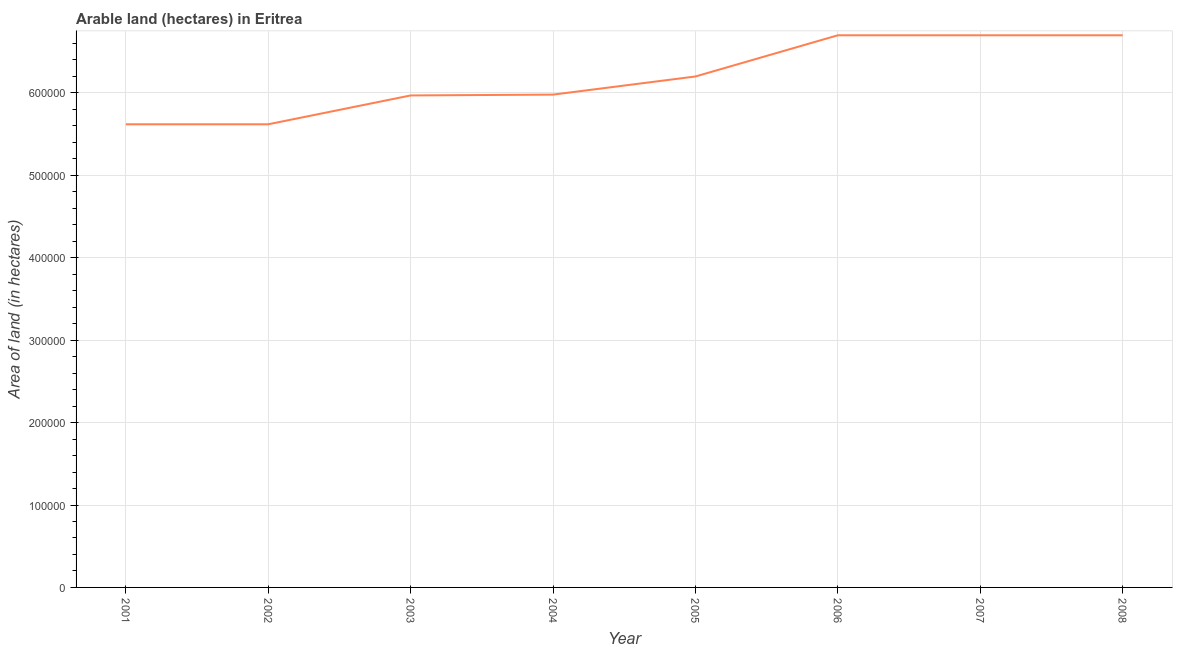What is the area of land in 2007?
Keep it short and to the point. 6.70e+05. Across all years, what is the maximum area of land?
Offer a terse response. 6.70e+05. Across all years, what is the minimum area of land?
Offer a very short reply. 5.62e+05. In which year was the area of land minimum?
Your response must be concise. 2001. What is the sum of the area of land?
Ensure brevity in your answer.  4.95e+06. What is the difference between the area of land in 2004 and 2008?
Provide a short and direct response. -7.20e+04. What is the average area of land per year?
Offer a very short reply. 6.19e+05. What is the median area of land?
Your answer should be very brief. 6.09e+05. Do a majority of the years between 2006 and 2007 (inclusive) have area of land greater than 600000 hectares?
Your answer should be very brief. Yes. What is the ratio of the area of land in 2004 to that in 2005?
Offer a terse response. 0.96. Is the area of land in 2001 less than that in 2004?
Ensure brevity in your answer.  Yes. What is the difference between the highest and the second highest area of land?
Make the answer very short. 0. Is the sum of the area of land in 2003 and 2005 greater than the maximum area of land across all years?
Ensure brevity in your answer.  Yes. What is the difference between the highest and the lowest area of land?
Provide a short and direct response. 1.08e+05. In how many years, is the area of land greater than the average area of land taken over all years?
Your answer should be compact. 4. Does the area of land monotonically increase over the years?
Your answer should be compact. No. How many years are there in the graph?
Offer a terse response. 8. Are the values on the major ticks of Y-axis written in scientific E-notation?
Your response must be concise. No. Does the graph contain any zero values?
Offer a terse response. No. Does the graph contain grids?
Your answer should be compact. Yes. What is the title of the graph?
Keep it short and to the point. Arable land (hectares) in Eritrea. What is the label or title of the Y-axis?
Provide a short and direct response. Area of land (in hectares). What is the Area of land (in hectares) of 2001?
Make the answer very short. 5.62e+05. What is the Area of land (in hectares) in 2002?
Provide a short and direct response. 5.62e+05. What is the Area of land (in hectares) in 2003?
Provide a short and direct response. 5.97e+05. What is the Area of land (in hectares) of 2004?
Give a very brief answer. 5.98e+05. What is the Area of land (in hectares) of 2005?
Provide a succinct answer. 6.20e+05. What is the Area of land (in hectares) of 2006?
Provide a succinct answer. 6.70e+05. What is the Area of land (in hectares) of 2007?
Your answer should be very brief. 6.70e+05. What is the Area of land (in hectares) in 2008?
Provide a succinct answer. 6.70e+05. What is the difference between the Area of land (in hectares) in 2001 and 2002?
Offer a terse response. 0. What is the difference between the Area of land (in hectares) in 2001 and 2003?
Ensure brevity in your answer.  -3.50e+04. What is the difference between the Area of land (in hectares) in 2001 and 2004?
Ensure brevity in your answer.  -3.60e+04. What is the difference between the Area of land (in hectares) in 2001 and 2005?
Provide a succinct answer. -5.80e+04. What is the difference between the Area of land (in hectares) in 2001 and 2006?
Your answer should be compact. -1.08e+05. What is the difference between the Area of land (in hectares) in 2001 and 2007?
Offer a very short reply. -1.08e+05. What is the difference between the Area of land (in hectares) in 2001 and 2008?
Ensure brevity in your answer.  -1.08e+05. What is the difference between the Area of land (in hectares) in 2002 and 2003?
Your answer should be compact. -3.50e+04. What is the difference between the Area of land (in hectares) in 2002 and 2004?
Provide a succinct answer. -3.60e+04. What is the difference between the Area of land (in hectares) in 2002 and 2005?
Offer a terse response. -5.80e+04. What is the difference between the Area of land (in hectares) in 2002 and 2006?
Provide a short and direct response. -1.08e+05. What is the difference between the Area of land (in hectares) in 2002 and 2007?
Your answer should be compact. -1.08e+05. What is the difference between the Area of land (in hectares) in 2002 and 2008?
Your response must be concise. -1.08e+05. What is the difference between the Area of land (in hectares) in 2003 and 2004?
Your answer should be compact. -1000. What is the difference between the Area of land (in hectares) in 2003 and 2005?
Ensure brevity in your answer.  -2.30e+04. What is the difference between the Area of land (in hectares) in 2003 and 2006?
Give a very brief answer. -7.30e+04. What is the difference between the Area of land (in hectares) in 2003 and 2007?
Provide a short and direct response. -7.30e+04. What is the difference between the Area of land (in hectares) in 2003 and 2008?
Ensure brevity in your answer.  -7.30e+04. What is the difference between the Area of land (in hectares) in 2004 and 2005?
Make the answer very short. -2.20e+04. What is the difference between the Area of land (in hectares) in 2004 and 2006?
Make the answer very short. -7.20e+04. What is the difference between the Area of land (in hectares) in 2004 and 2007?
Your response must be concise. -7.20e+04. What is the difference between the Area of land (in hectares) in 2004 and 2008?
Keep it short and to the point. -7.20e+04. What is the difference between the Area of land (in hectares) in 2005 and 2006?
Your response must be concise. -5.00e+04. What is the difference between the Area of land (in hectares) in 2005 and 2007?
Keep it short and to the point. -5.00e+04. What is the difference between the Area of land (in hectares) in 2006 and 2007?
Your answer should be very brief. 0. What is the difference between the Area of land (in hectares) in 2006 and 2008?
Your answer should be very brief. 0. What is the ratio of the Area of land (in hectares) in 2001 to that in 2002?
Make the answer very short. 1. What is the ratio of the Area of land (in hectares) in 2001 to that in 2003?
Make the answer very short. 0.94. What is the ratio of the Area of land (in hectares) in 2001 to that in 2004?
Make the answer very short. 0.94. What is the ratio of the Area of land (in hectares) in 2001 to that in 2005?
Make the answer very short. 0.91. What is the ratio of the Area of land (in hectares) in 2001 to that in 2006?
Ensure brevity in your answer.  0.84. What is the ratio of the Area of land (in hectares) in 2001 to that in 2007?
Offer a very short reply. 0.84. What is the ratio of the Area of land (in hectares) in 2001 to that in 2008?
Provide a short and direct response. 0.84. What is the ratio of the Area of land (in hectares) in 2002 to that in 2003?
Your answer should be very brief. 0.94. What is the ratio of the Area of land (in hectares) in 2002 to that in 2004?
Your answer should be compact. 0.94. What is the ratio of the Area of land (in hectares) in 2002 to that in 2005?
Provide a succinct answer. 0.91. What is the ratio of the Area of land (in hectares) in 2002 to that in 2006?
Give a very brief answer. 0.84. What is the ratio of the Area of land (in hectares) in 2002 to that in 2007?
Your answer should be compact. 0.84. What is the ratio of the Area of land (in hectares) in 2002 to that in 2008?
Your answer should be very brief. 0.84. What is the ratio of the Area of land (in hectares) in 2003 to that in 2006?
Offer a terse response. 0.89. What is the ratio of the Area of land (in hectares) in 2003 to that in 2007?
Offer a very short reply. 0.89. What is the ratio of the Area of land (in hectares) in 2003 to that in 2008?
Your answer should be compact. 0.89. What is the ratio of the Area of land (in hectares) in 2004 to that in 2005?
Keep it short and to the point. 0.96. What is the ratio of the Area of land (in hectares) in 2004 to that in 2006?
Your answer should be compact. 0.89. What is the ratio of the Area of land (in hectares) in 2004 to that in 2007?
Give a very brief answer. 0.89. What is the ratio of the Area of land (in hectares) in 2004 to that in 2008?
Offer a very short reply. 0.89. What is the ratio of the Area of land (in hectares) in 2005 to that in 2006?
Your answer should be very brief. 0.93. What is the ratio of the Area of land (in hectares) in 2005 to that in 2007?
Keep it short and to the point. 0.93. What is the ratio of the Area of land (in hectares) in 2005 to that in 2008?
Offer a very short reply. 0.93. What is the ratio of the Area of land (in hectares) in 2006 to that in 2008?
Your answer should be very brief. 1. What is the ratio of the Area of land (in hectares) in 2007 to that in 2008?
Keep it short and to the point. 1. 